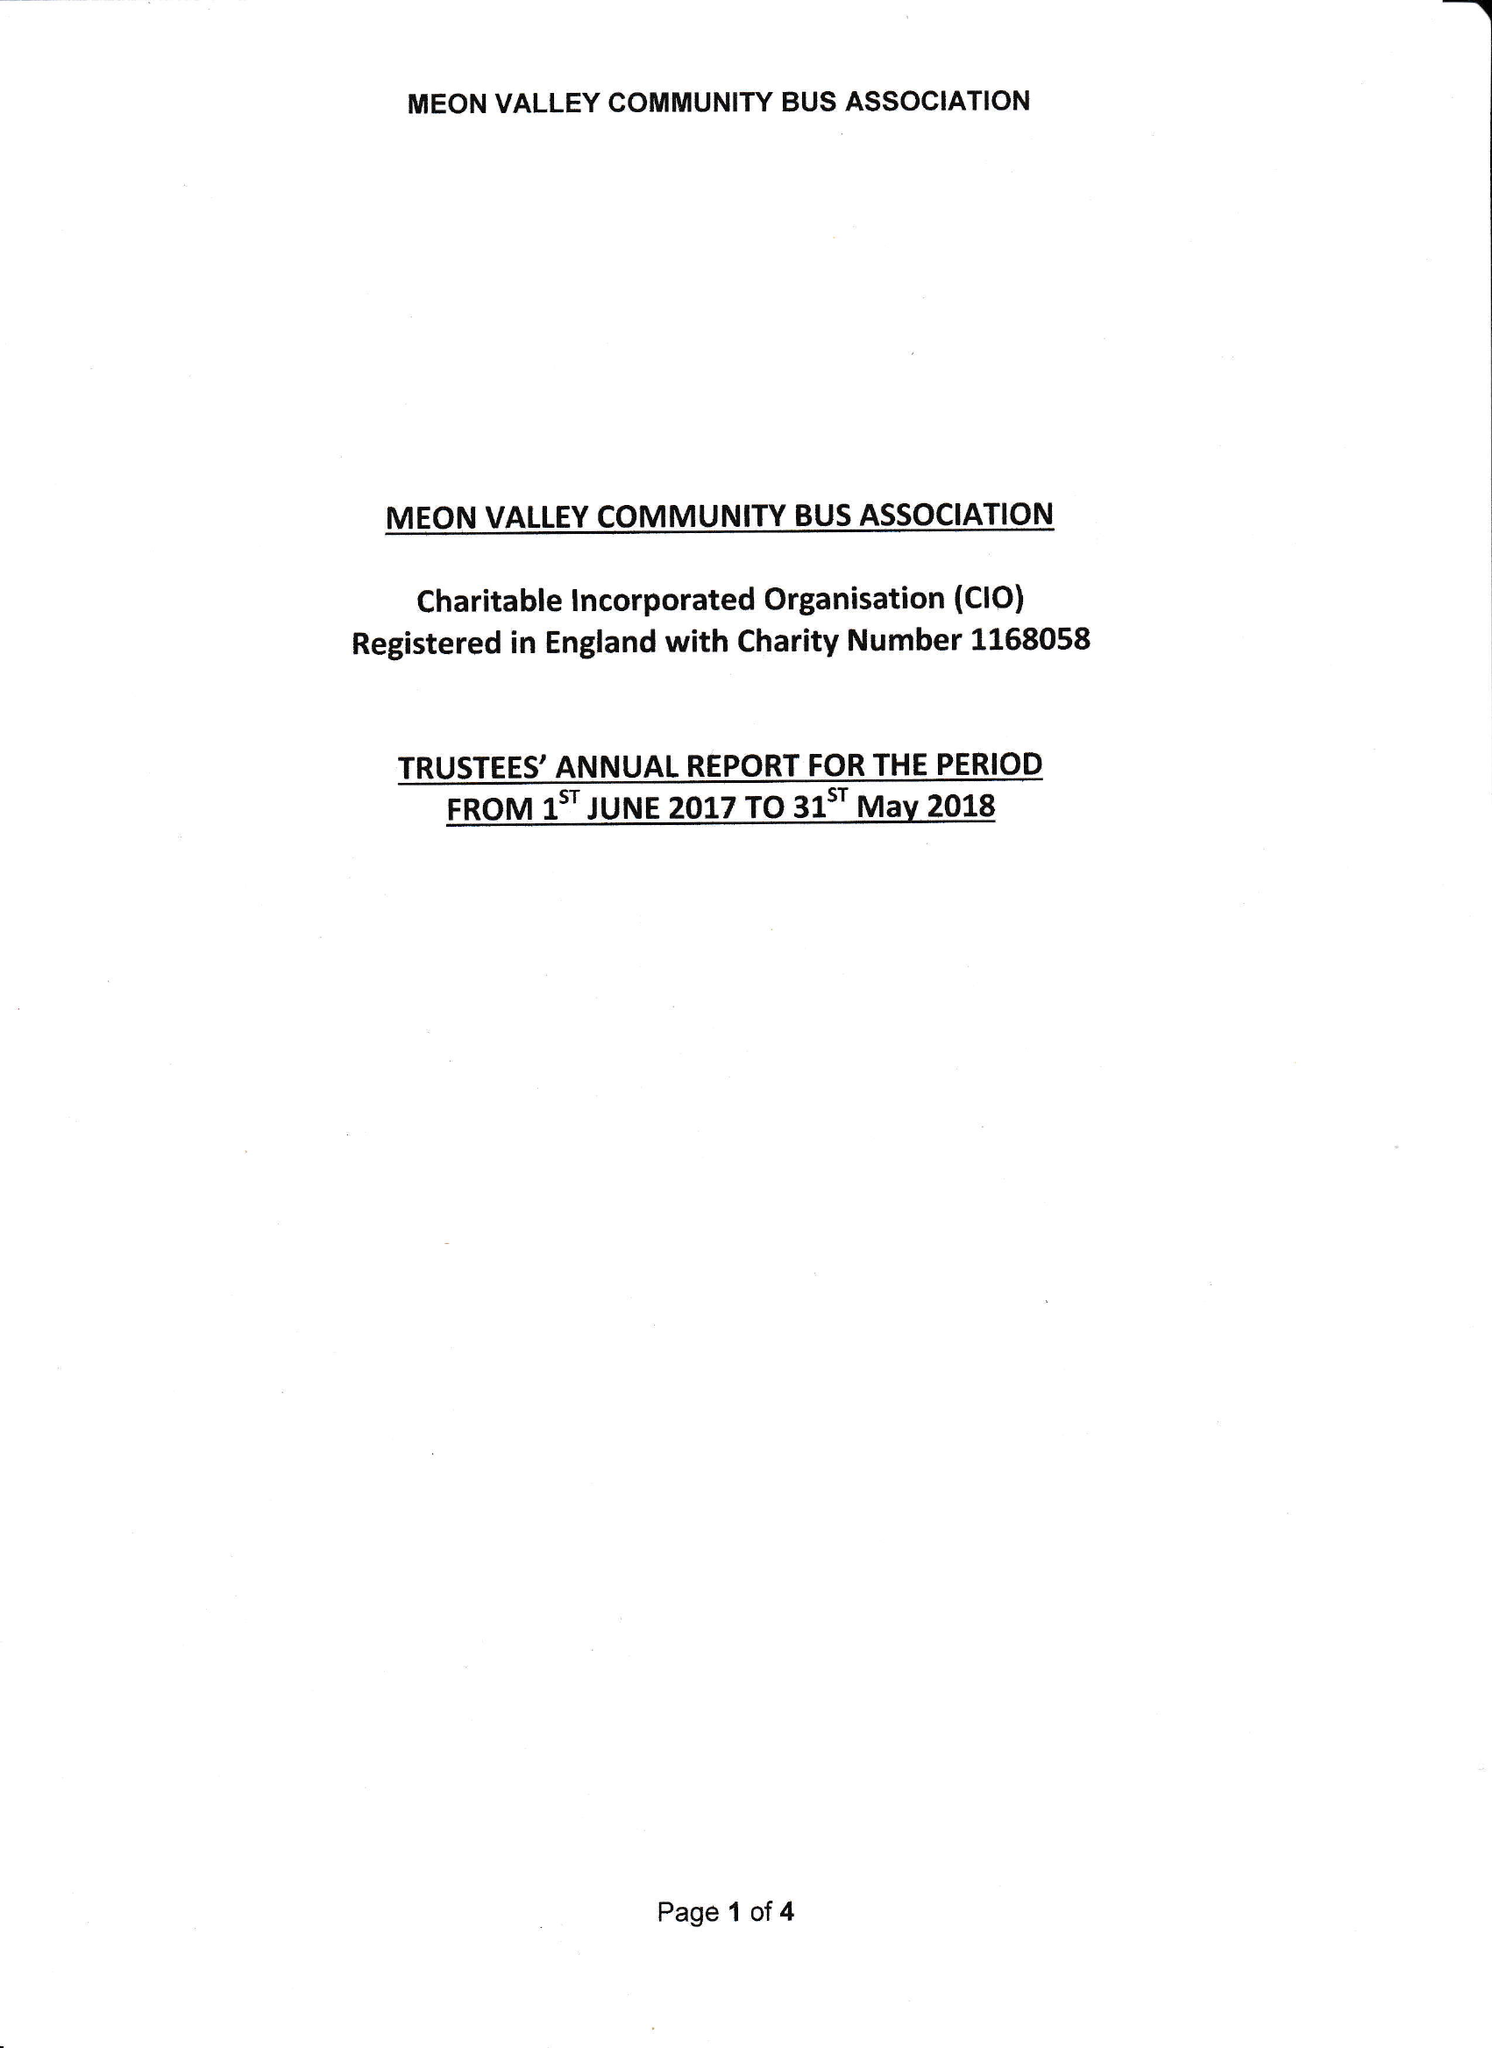What is the value for the spending_annually_in_british_pounds?
Answer the question using a single word or phrase. 5234.00 